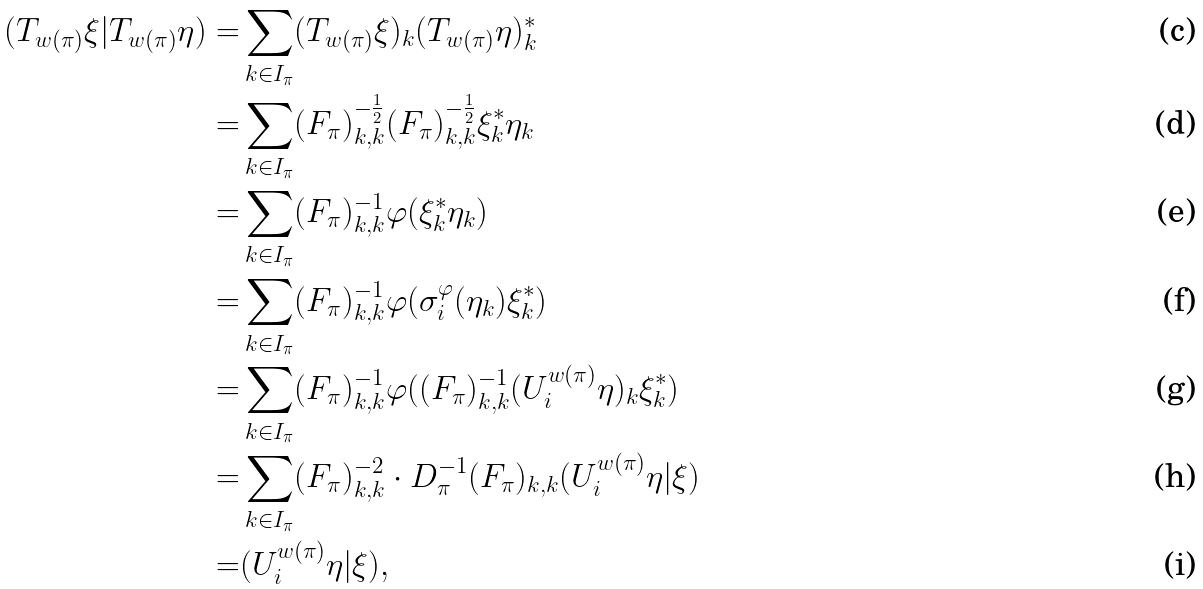<formula> <loc_0><loc_0><loc_500><loc_500>( T _ { w ( \pi ) } \xi | T _ { w ( \pi ) } \eta ) = & \sum _ { k \in I _ { \pi } } ( T _ { w ( \pi ) } \xi ) _ { k } ( T _ { w ( \pi ) } \eta ) ^ { * } _ { k } \\ = & \sum _ { k \in I _ { \pi } } ( F _ { \pi } ) ^ { - \frac { 1 } { 2 } } _ { k , k } ( F _ { \pi } ) ^ { - \frac { 1 } { 2 } } _ { k , k } \xi _ { k } ^ { * } \eta _ { k } \\ = & \sum _ { k \in I _ { \pi } } ( F _ { \pi } ) ^ { - 1 } _ { k , k } \varphi ( \xi _ { k } ^ { * } \eta _ { k } ) \\ = & \sum _ { k \in I _ { \pi } } ( F _ { \pi } ) ^ { - 1 } _ { k , k } \varphi ( \sigma ^ { \varphi } _ { i } ( \eta _ { k } ) \xi _ { k } ^ { * } ) \\ = & \sum _ { k \in I _ { \pi } } ( F _ { \pi } ) ^ { - 1 } _ { k , k } \varphi ( ( F _ { \pi } ) ^ { - 1 } _ { k , k } ( U ^ { w ( \pi ) } _ { i } \eta ) _ { k } \xi _ { k } ^ { * } ) \\ = & \sum _ { k \in I _ { \pi } } ( F _ { \pi } ) ^ { - 2 } _ { k , k } \cdot D _ { \pi } ^ { - 1 } ( F _ { \pi } ) _ { k , k } ( U ^ { w ( \pi ) } _ { i } \eta | \xi ) \\ = & ( U ^ { w ( \pi ) } _ { i } \eta | \xi ) ,</formula> 